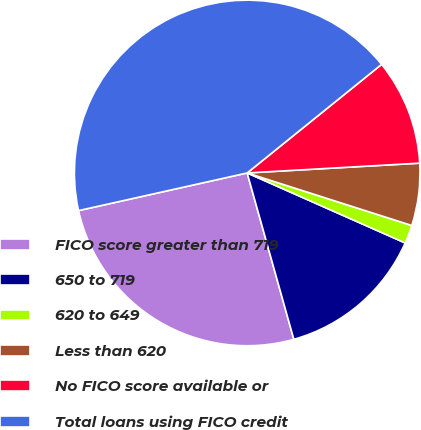<chart> <loc_0><loc_0><loc_500><loc_500><pie_chart><fcel>FICO score greater than 719<fcel>650 to 719<fcel>620 to 649<fcel>Less than 620<fcel>No FICO score available or<fcel>Total loans using FICO credit<nl><fcel>25.85%<fcel>14.01%<fcel>1.72%<fcel>5.82%<fcel>9.91%<fcel>42.68%<nl></chart> 